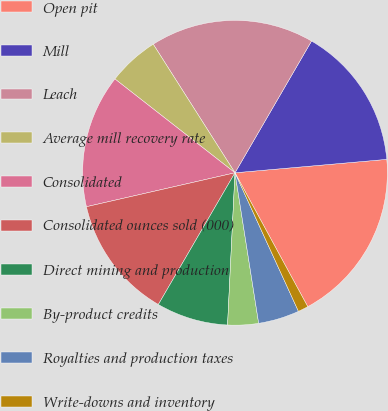Convert chart to OTSL. <chart><loc_0><loc_0><loc_500><loc_500><pie_chart><fcel>Open pit<fcel>Mill<fcel>Leach<fcel>Average mill recovery rate<fcel>Consolidated<fcel>Consolidated ounces sold (000)<fcel>Direct mining and production<fcel>By-product credits<fcel>Royalties and production taxes<fcel>Write-downs and inventory<nl><fcel>18.48%<fcel>15.22%<fcel>17.39%<fcel>5.43%<fcel>14.13%<fcel>13.04%<fcel>7.61%<fcel>3.26%<fcel>4.35%<fcel>1.09%<nl></chart> 